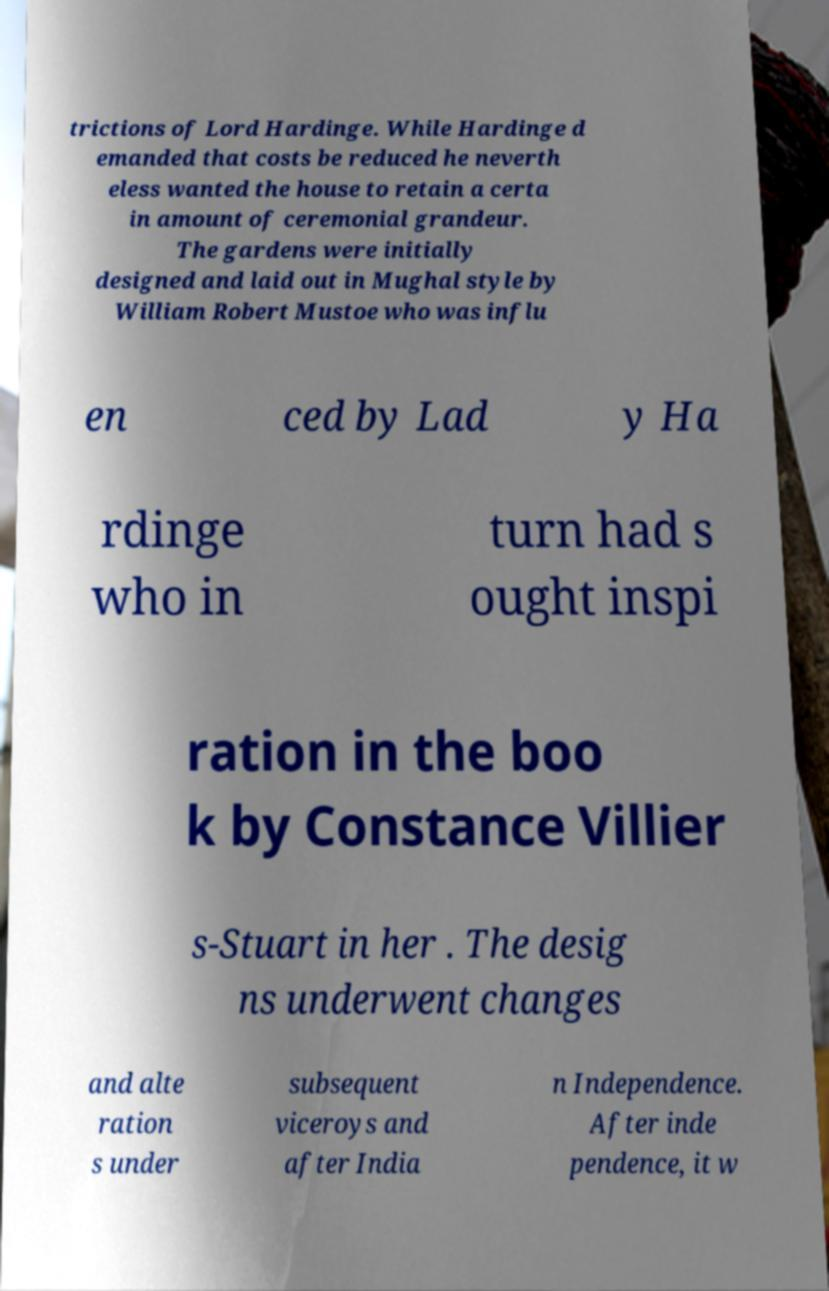Please read and relay the text visible in this image. What does it say? trictions of Lord Hardinge. While Hardinge d emanded that costs be reduced he neverth eless wanted the house to retain a certa in amount of ceremonial grandeur. The gardens were initially designed and laid out in Mughal style by William Robert Mustoe who was influ en ced by Lad y Ha rdinge who in turn had s ought inspi ration in the boo k by Constance Villier s-Stuart in her . The desig ns underwent changes and alte ration s under subsequent viceroys and after India n Independence. After inde pendence, it w 